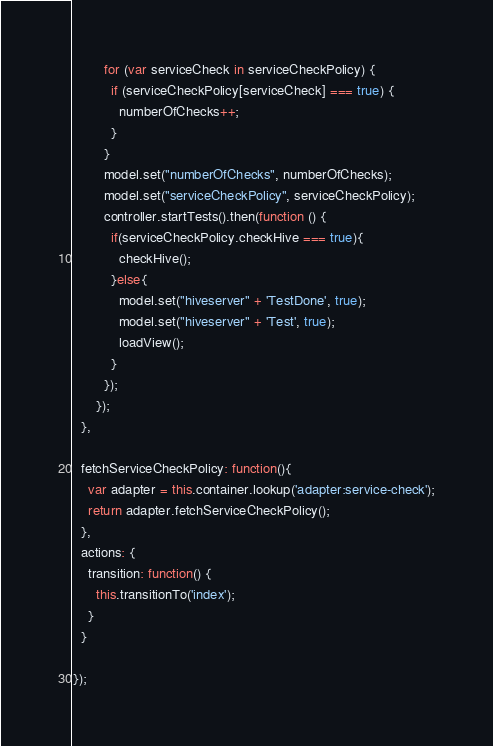<code> <loc_0><loc_0><loc_500><loc_500><_JavaScript_>        for (var serviceCheck in serviceCheckPolicy) {
          if (serviceCheckPolicy[serviceCheck] === true) {
            numberOfChecks++;
          }
        }
        model.set("numberOfChecks", numberOfChecks);
        model.set("serviceCheckPolicy", serviceCheckPolicy);
        controller.startTests().then(function () {
          if(serviceCheckPolicy.checkHive === true){
            checkHive();
          }else{
            model.set("hiveserver" + 'TestDone', true);
            model.set("hiveserver" + 'Test', true);
            loadView();
          }
        });
      });
  },

  fetchServiceCheckPolicy: function(){
    var adapter = this.container.lookup('adapter:service-check');
    return adapter.fetchServiceCheckPolicy();
  },
  actions: {
    transition: function() {
      this.transitionTo('index');
    }
  }

});
</code> 